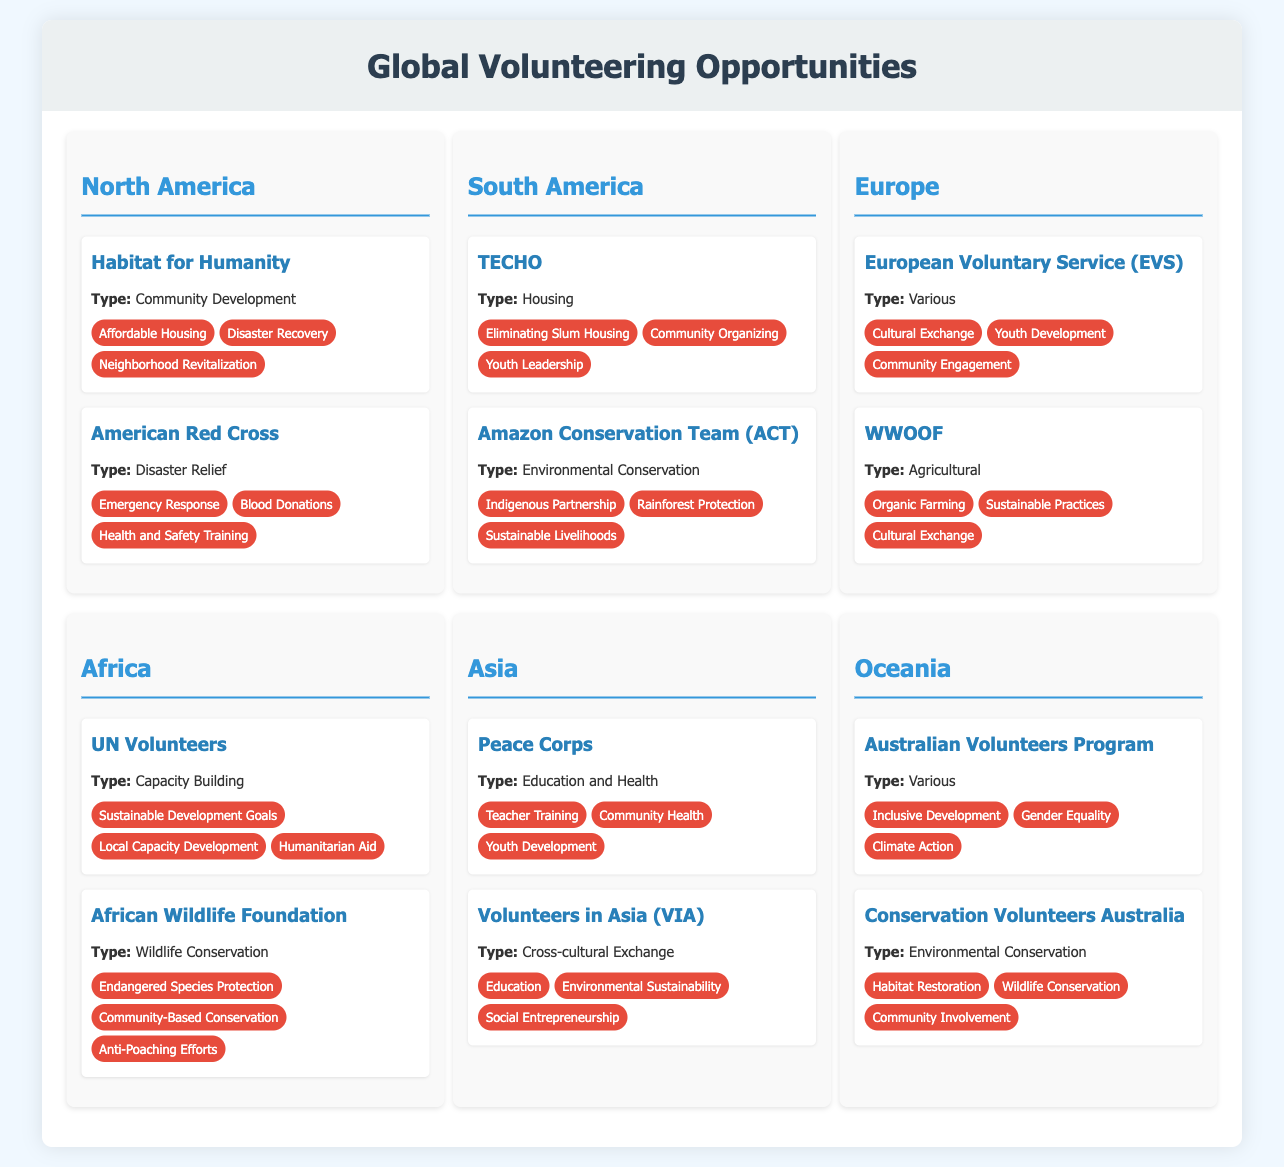What is the type of the Habitat for Humanity project? The document states that Habitat for Humanity is a Community Development project.
Answer: Community Development Which project focuses on eliminating slum housing in South America? The TECHO project in South America focuses on eliminating slum housing.
Answer: TECHO How many impact factors are listed for the American Red Cross? The American Red Cross has three impact factors listed in the document.
Answer: 3 What type of project is UN Volunteers classified as? According to the document, UN Volunteers is classified as a Capacity Building project.
Answer: Capacity Building Which region has a project for Environmental Conservation called Conservation Volunteers Australia? The Conservation Volunteers Australia project is located in the Oceania region.
Answer: Oceania Which impact factor is associated with the Amazon Conservation Team (ACT)? One of the impact factors associated with ACT is Rainforest Protection.
Answer: Rainforest Protection What type of opportunities does the European Voluntary Service (EVS) encompass? The document indicates that EVS encompasses various types of opportunities.
Answer: Various Which project is focused on community health in Asia? The Peace Corps project focuses on community health in Asia.
Answer: Peace Corps What is the main goal of the African Wildlife Foundation project? The main goal includes Endangered Species Protection as stated in the document.
Answer: Endangered Species Protection 